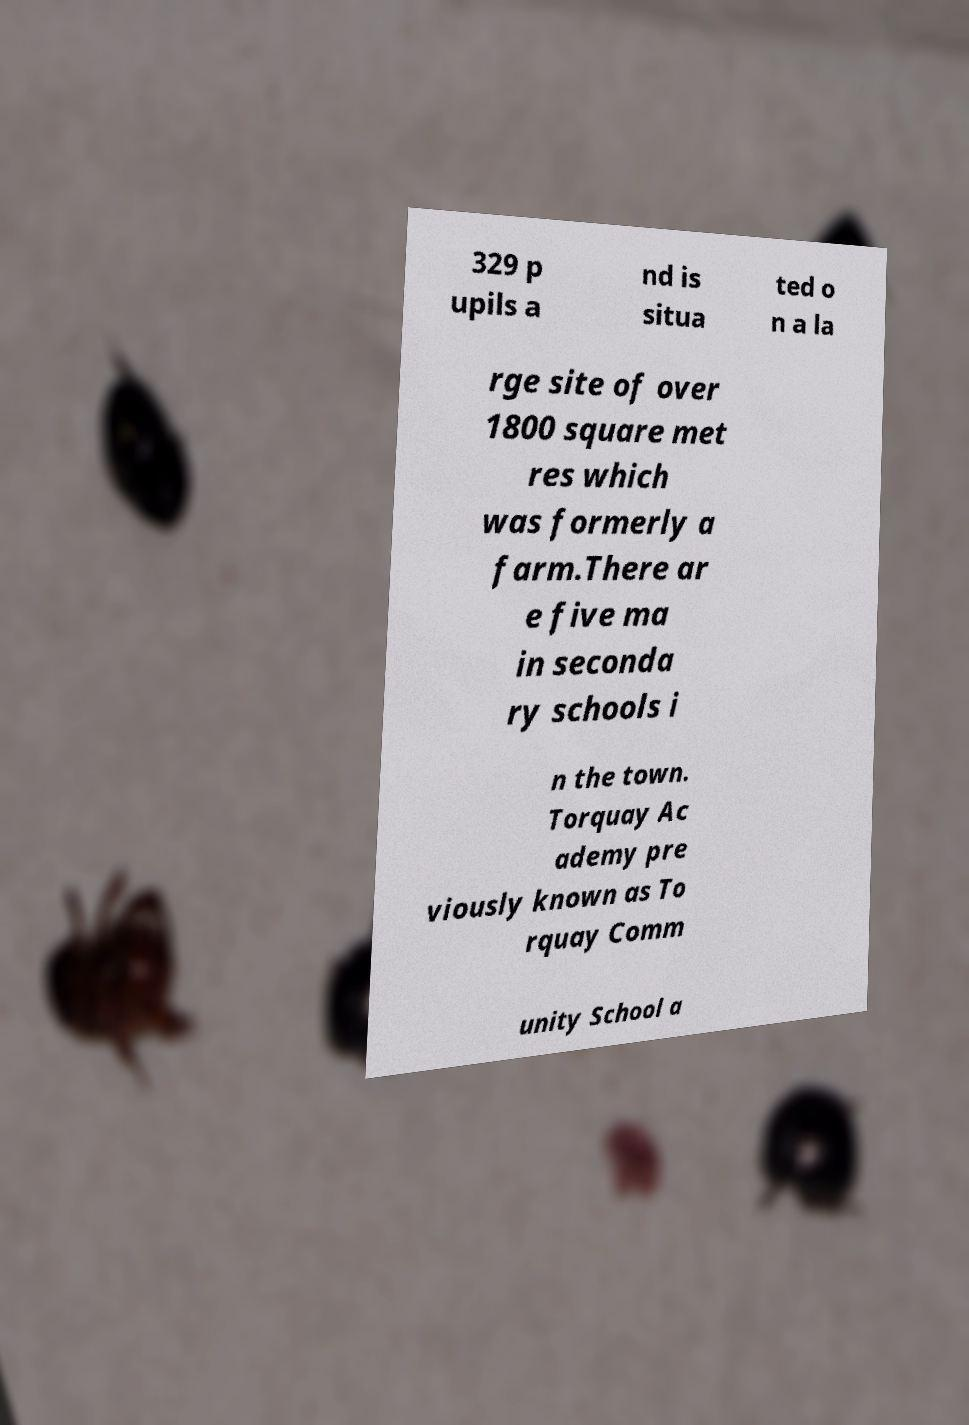Can you accurately transcribe the text from the provided image for me? 329 p upils a nd is situa ted o n a la rge site of over 1800 square met res which was formerly a farm.There ar e five ma in seconda ry schools i n the town. Torquay Ac ademy pre viously known as To rquay Comm unity School a 